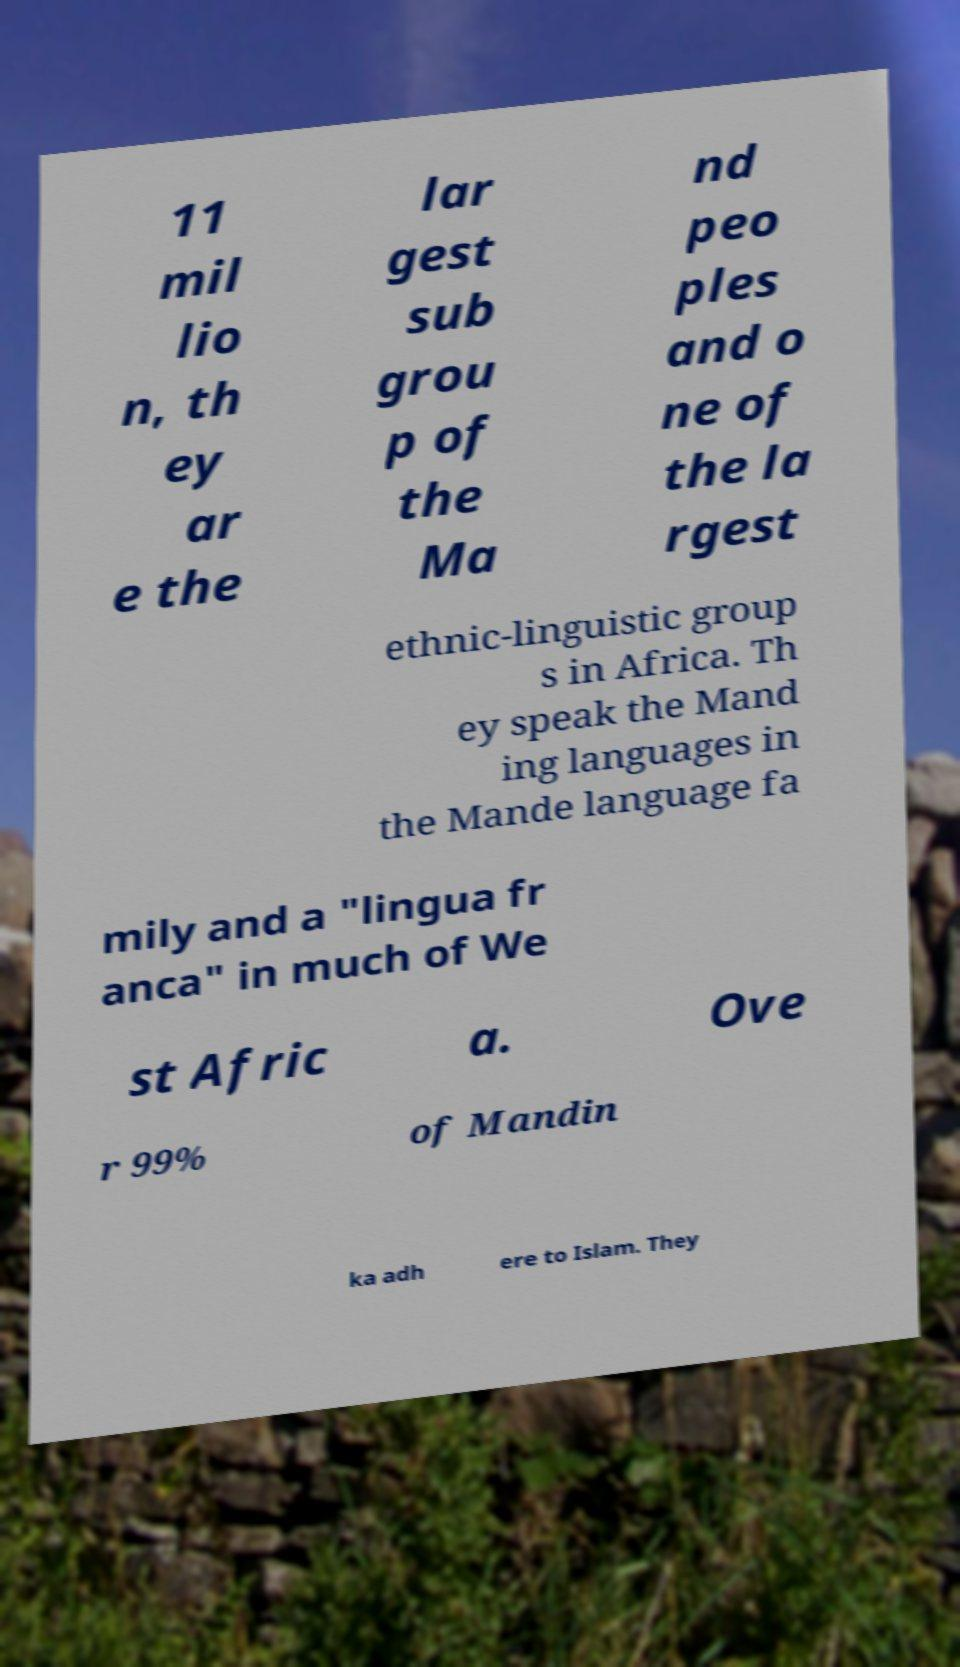I need the written content from this picture converted into text. Can you do that? 11 mil lio n, th ey ar e the lar gest sub grou p of the Ma nd peo ples and o ne of the la rgest ethnic-linguistic group s in Africa. Th ey speak the Mand ing languages in the Mande language fa mily and a "lingua fr anca" in much of We st Afric a. Ove r 99% of Mandin ka adh ere to Islam. They 